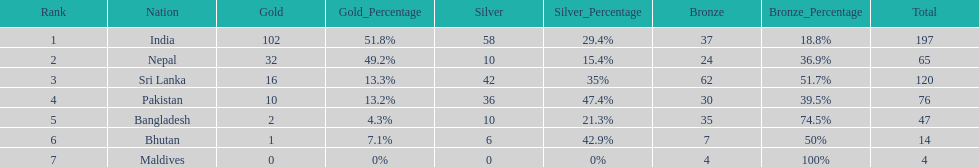What are the total number of bronze medals sri lanka have earned? 62. 